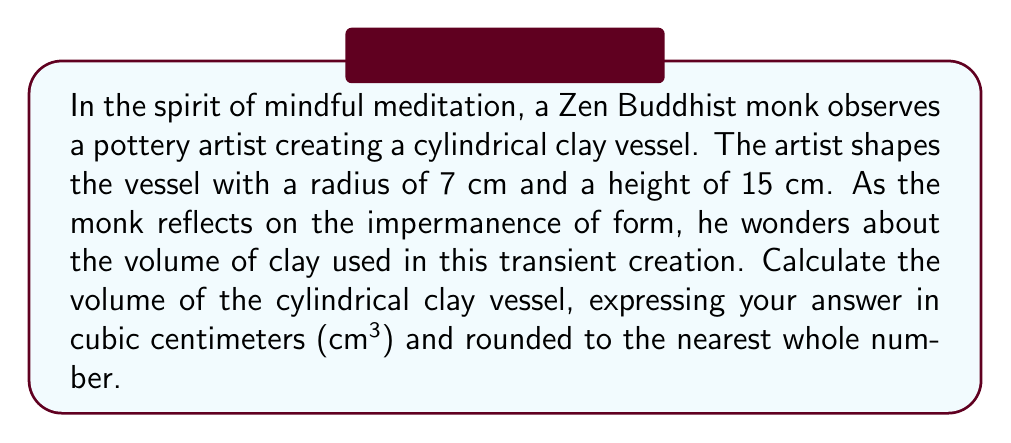Can you answer this question? To calculate the volume of a cylindrical clay vessel, we use the formula for the volume of a cylinder:

$$V = \pi r^2 h$$

Where:
$V$ = volume
$\pi$ = pi (approximately 3.14159)
$r$ = radius of the base
$h$ = height of the cylinder

Given:
$r = 7$ cm
$h = 15$ cm

Let's substitute these values into the formula:

$$V = \pi (7 \text{ cm})^2 (15 \text{ cm})$$

Now, let's calculate step by step:

1) First, calculate $r^2$:
   $7^2 = 49$ cm²

2) Multiply by $\pi$:
   $\pi \cdot 49 \text{ cm}^2 \approx 153.94$ cm²

3) Multiply by the height:
   $153.94 \text{ cm}^2 \cdot 15 \text{ cm} \approx 2,309.10$ cm³

4) Round to the nearest whole number:
   $2,309.10 \text{ cm}^3 \approx 2,309 \text{ cm}^3$

Thus, the volume of the cylindrical clay vessel is approximately 2,309 cm³.

[asy]
import geometry;

size(200);

// Draw cylinder
path base = Circle((0,0),7);
path top = Circle((0,15),7);
draw(base);
draw(top);
draw((7,0)--(7,15));
draw((-7,0)--(-7,15));

// Labels
label("r = 7 cm", (8,7.5), E);
label("h = 15 cm", (0,7.5), W);

// Dashed lines
draw((0,0)--(7,0), dashed);
draw((0,15)--(7,15), dashed);
[/asy]
Answer: The volume of the cylindrical clay vessel is approximately 2,309 cm³. 